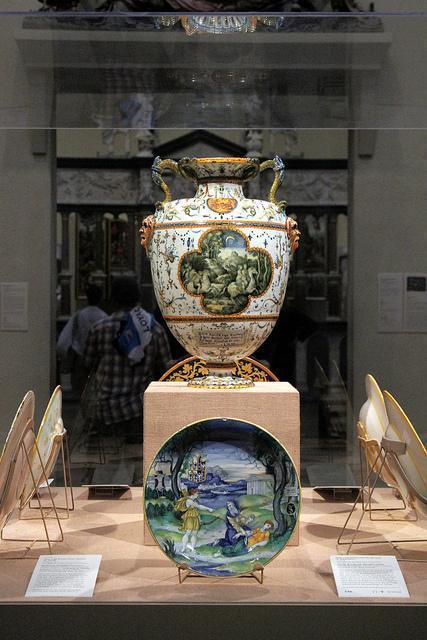How many plates?
Give a very brief answer. 5. How many people are visible?
Give a very brief answer. 2. How many legs is the bear standing on?
Give a very brief answer. 0. 